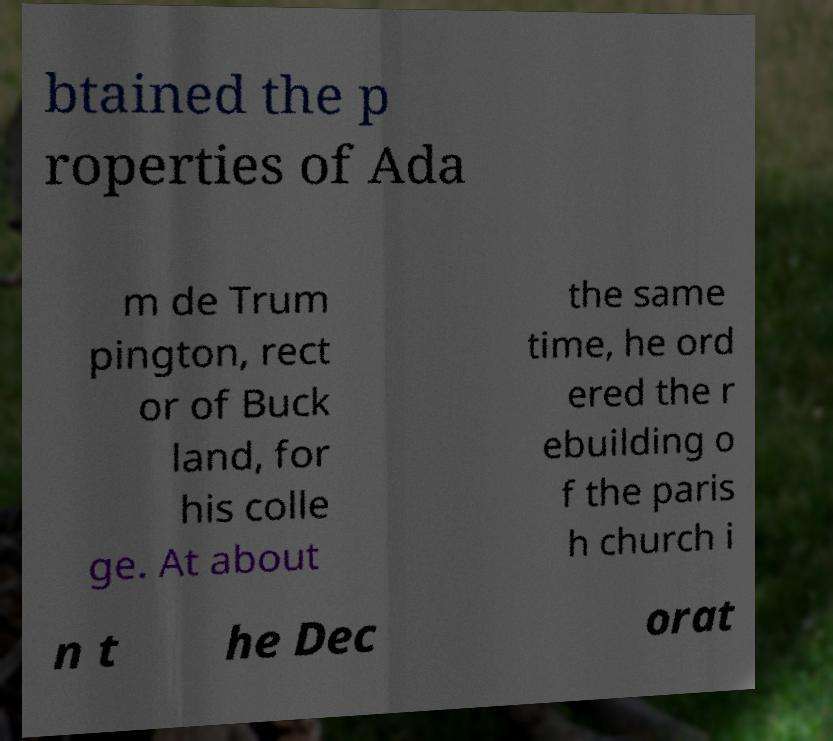Could you extract and type out the text from this image? btained the p roperties of Ada m de Trum pington, rect or of Buck land, for his colle ge. At about the same time, he ord ered the r ebuilding o f the paris h church i n t he Dec orat 